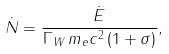Convert formula to latex. <formula><loc_0><loc_0><loc_500><loc_500>\dot { N } = \frac { \dot { E } } { \Gamma _ { W } \, m _ { e } c ^ { 2 } \, ( 1 + \sigma ) } ,</formula> 